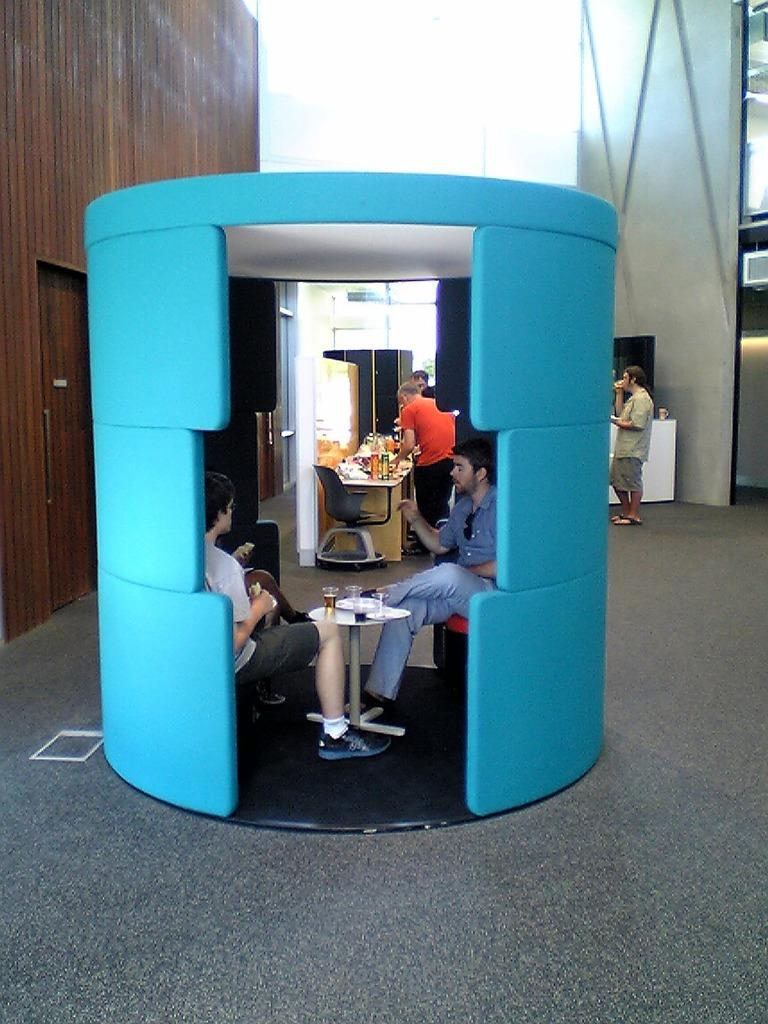What are the people in the image doing? The people in the image are sitting on chairs. What can be seen on the table in the image? There are wine bottles and wine glasses on the table. Are there any people standing in the image? Yes, there are people standing at the back in the image. What type of bear can be seen drinking soda in the image? There is no bear or soda present in the image. Can you tell me how many beetles are crawling on the table in the image? There are no beetles present on the table in the image. 